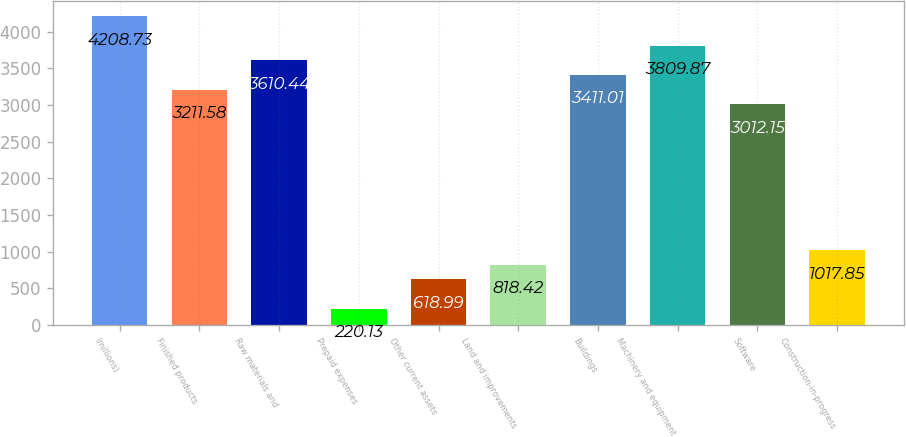<chart> <loc_0><loc_0><loc_500><loc_500><bar_chart><fcel>(millions)<fcel>Finished products<fcel>Raw materials and<fcel>Prepaid expenses<fcel>Other current assets<fcel>Land and improvements<fcel>Buildings<fcel>Machinery and equipment<fcel>Software<fcel>Construction-in-progress<nl><fcel>4208.73<fcel>3211.58<fcel>3610.44<fcel>220.13<fcel>618.99<fcel>818.42<fcel>3411.01<fcel>3809.87<fcel>3012.15<fcel>1017.85<nl></chart> 